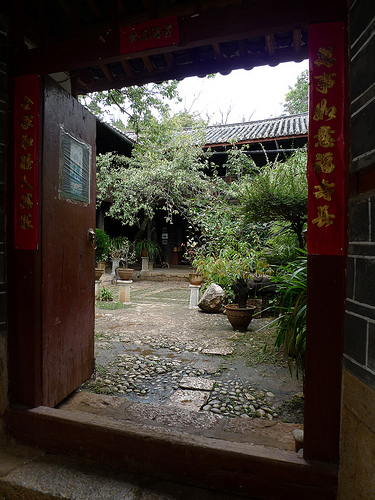<image>
Is the plant in front of the step? Yes. The plant is positioned in front of the step, appearing closer to the camera viewpoint. 